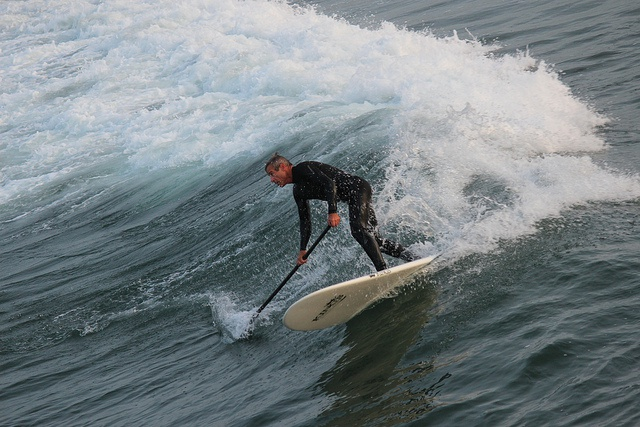Describe the objects in this image and their specific colors. I can see people in darkgray, black, gray, maroon, and brown tones and surfboard in darkgray, gray, and lightgray tones in this image. 